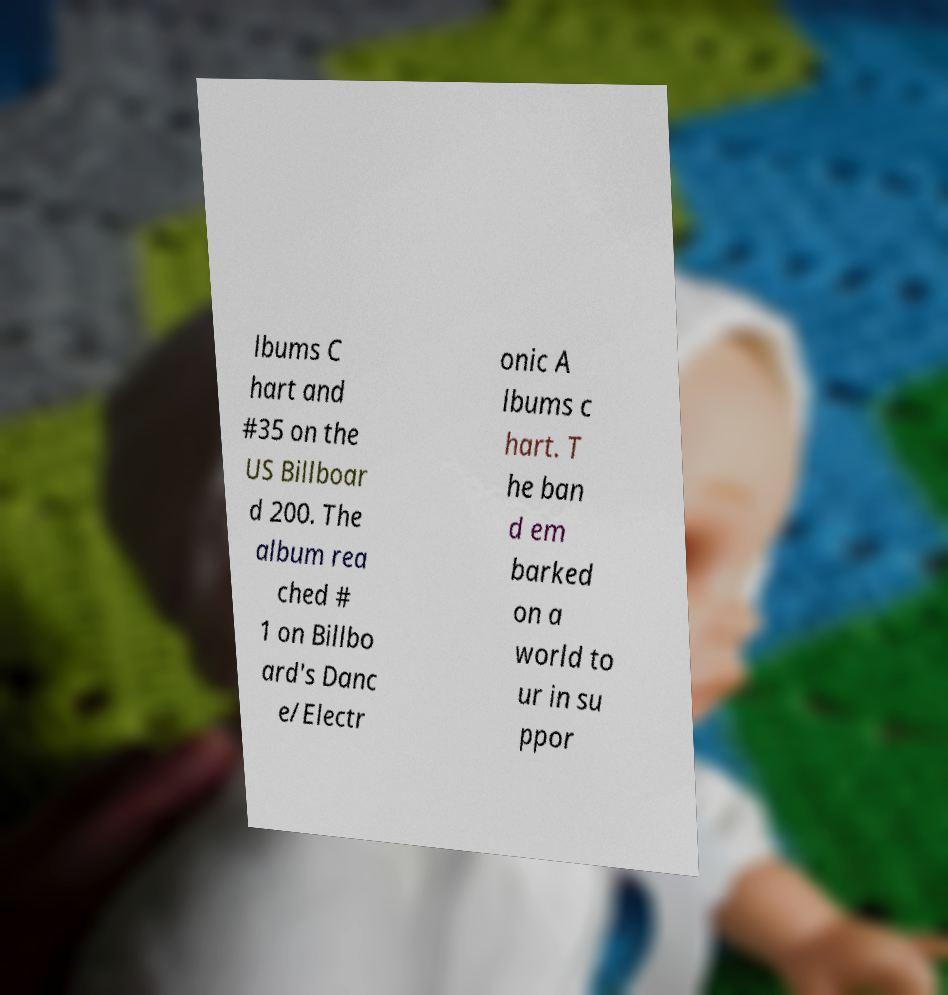Can you accurately transcribe the text from the provided image for me? lbums C hart and #35 on the US Billboar d 200. The album rea ched # 1 on Billbo ard's Danc e/Electr onic A lbums c hart. T he ban d em barked on a world to ur in su ppor 